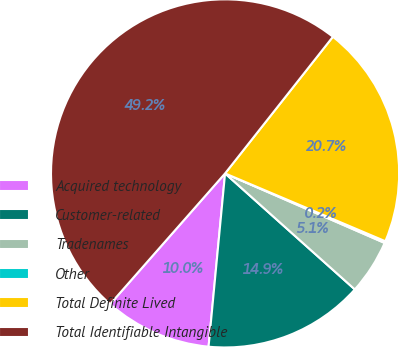<chart> <loc_0><loc_0><loc_500><loc_500><pie_chart><fcel>Acquired technology<fcel>Customer-related<fcel>Tradenames<fcel>Other<fcel>Total Definite Lived<fcel>Total Identifiable Intangible<nl><fcel>9.97%<fcel>14.9%<fcel>5.07%<fcel>0.17%<fcel>20.74%<fcel>49.15%<nl></chart> 